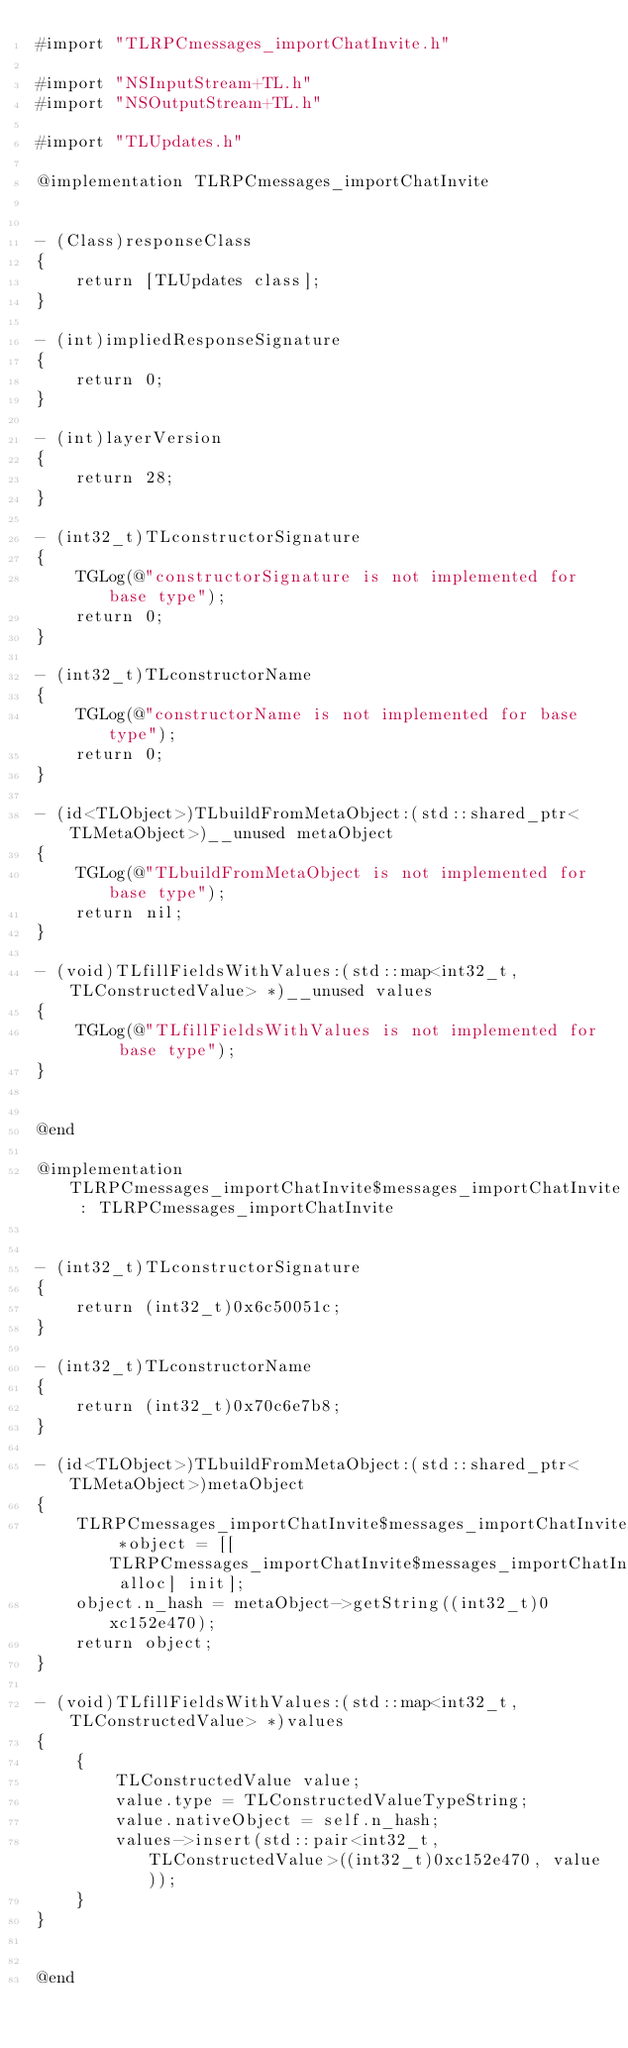Convert code to text. <code><loc_0><loc_0><loc_500><loc_500><_ObjectiveC_>#import "TLRPCmessages_importChatInvite.h"

#import "NSInputStream+TL.h"
#import "NSOutputStream+TL.h"

#import "TLUpdates.h"

@implementation TLRPCmessages_importChatInvite


- (Class)responseClass
{
    return [TLUpdates class];
}

- (int)impliedResponseSignature
{
    return 0;
}

- (int)layerVersion
{
    return 28;
}

- (int32_t)TLconstructorSignature
{
    TGLog(@"constructorSignature is not implemented for base type");
    return 0;
}

- (int32_t)TLconstructorName
{
    TGLog(@"constructorName is not implemented for base type");
    return 0;
}

- (id<TLObject>)TLbuildFromMetaObject:(std::shared_ptr<TLMetaObject>)__unused metaObject
{
    TGLog(@"TLbuildFromMetaObject is not implemented for base type");
    return nil;
}

- (void)TLfillFieldsWithValues:(std::map<int32_t, TLConstructedValue> *)__unused values
{
    TGLog(@"TLfillFieldsWithValues is not implemented for base type");
}


@end

@implementation TLRPCmessages_importChatInvite$messages_importChatInvite : TLRPCmessages_importChatInvite


- (int32_t)TLconstructorSignature
{
    return (int32_t)0x6c50051c;
}

- (int32_t)TLconstructorName
{
    return (int32_t)0x70c6e7b8;
}

- (id<TLObject>)TLbuildFromMetaObject:(std::shared_ptr<TLMetaObject>)metaObject
{
    TLRPCmessages_importChatInvite$messages_importChatInvite *object = [[TLRPCmessages_importChatInvite$messages_importChatInvite alloc] init];
    object.n_hash = metaObject->getString((int32_t)0xc152e470);
    return object;
}

- (void)TLfillFieldsWithValues:(std::map<int32_t, TLConstructedValue> *)values
{
    {
        TLConstructedValue value;
        value.type = TLConstructedValueTypeString;
        value.nativeObject = self.n_hash;
        values->insert(std::pair<int32_t, TLConstructedValue>((int32_t)0xc152e470, value));
    }
}


@end

</code> 